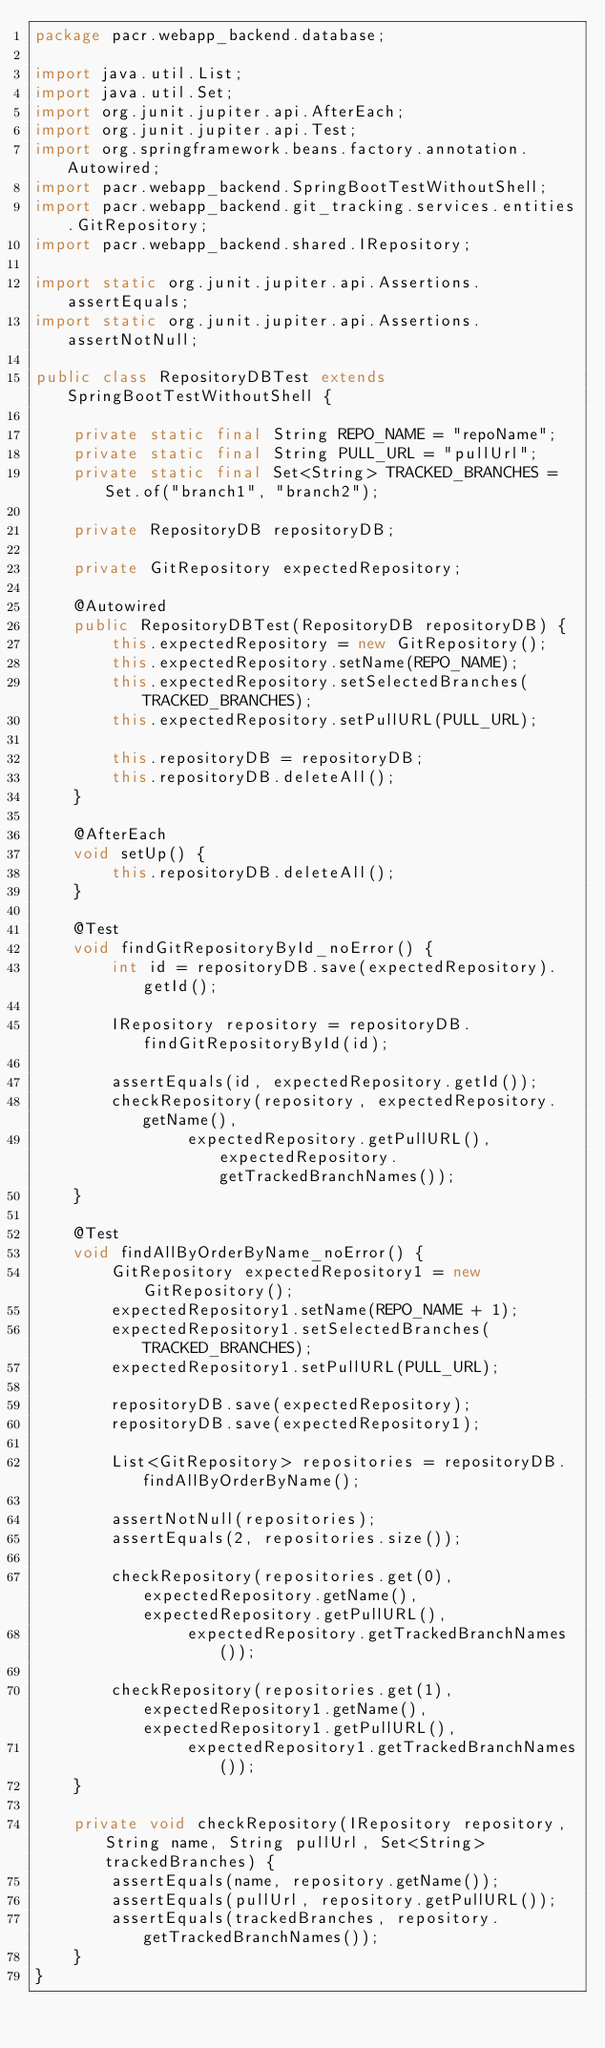<code> <loc_0><loc_0><loc_500><loc_500><_Java_>package pacr.webapp_backend.database;

import java.util.List;
import java.util.Set;
import org.junit.jupiter.api.AfterEach;
import org.junit.jupiter.api.Test;
import org.springframework.beans.factory.annotation.Autowired;
import pacr.webapp_backend.SpringBootTestWithoutShell;
import pacr.webapp_backend.git_tracking.services.entities.GitRepository;
import pacr.webapp_backend.shared.IRepository;

import static org.junit.jupiter.api.Assertions.assertEquals;
import static org.junit.jupiter.api.Assertions.assertNotNull;

public class RepositoryDBTest extends SpringBootTestWithoutShell {

    private static final String REPO_NAME = "repoName";
    private static final String PULL_URL = "pullUrl";
    private static final Set<String> TRACKED_BRANCHES = Set.of("branch1", "branch2");

    private RepositoryDB repositoryDB;

    private GitRepository expectedRepository;

    @Autowired
    public RepositoryDBTest(RepositoryDB repositoryDB) {
        this.expectedRepository = new GitRepository();
        this.expectedRepository.setName(REPO_NAME);
        this.expectedRepository.setSelectedBranches(TRACKED_BRANCHES);
        this.expectedRepository.setPullURL(PULL_URL);

        this.repositoryDB = repositoryDB;
        this.repositoryDB.deleteAll();
    }

    @AfterEach
    void setUp() {
        this.repositoryDB.deleteAll();
    }

    @Test
    void findGitRepositoryById_noError() {
        int id = repositoryDB.save(expectedRepository).getId();

        IRepository repository = repositoryDB.findGitRepositoryById(id);

        assertEquals(id, expectedRepository.getId());
        checkRepository(repository, expectedRepository.getName(),
                expectedRepository.getPullURL(), expectedRepository.getTrackedBranchNames());
    }

    @Test
    void findAllByOrderByName_noError() {
        GitRepository expectedRepository1 = new GitRepository();
        expectedRepository1.setName(REPO_NAME + 1);
        expectedRepository1.setSelectedBranches(TRACKED_BRANCHES);
        expectedRepository1.setPullURL(PULL_URL);

        repositoryDB.save(expectedRepository);
        repositoryDB.save(expectedRepository1);

        List<GitRepository> repositories = repositoryDB.findAllByOrderByName();

        assertNotNull(repositories);
        assertEquals(2, repositories.size());

        checkRepository(repositories.get(0), expectedRepository.getName(), expectedRepository.getPullURL(),
                expectedRepository.getTrackedBranchNames());

        checkRepository(repositories.get(1), expectedRepository1.getName(), expectedRepository1.getPullURL(),
                expectedRepository1.getTrackedBranchNames());
    }

    private void checkRepository(IRepository repository, String name, String pullUrl, Set<String> trackedBranches) {
        assertEquals(name, repository.getName());
        assertEquals(pullUrl, repository.getPullURL());
        assertEquals(trackedBranches, repository.getTrackedBranchNames());
    }
}
</code> 